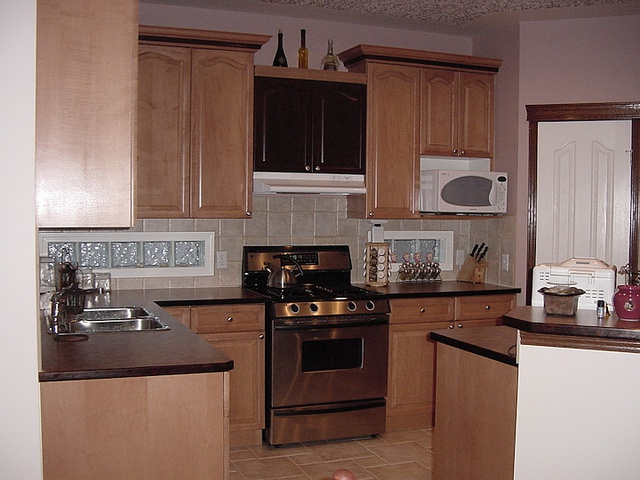Describe the objects in this image and their specific colors. I can see oven in darkgray, black, maroon, and gray tones, microwave in darkgray, gray, and black tones, sink in darkgray, gray, black, and white tones, vase in darkgray, maroon, and brown tones, and bottle in darkgray, black, maroon, and gray tones in this image. 